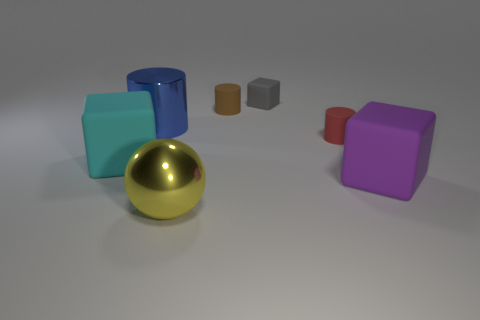Is the big purple block made of the same material as the yellow ball?
Your response must be concise. No. What number of other things are the same color as the large shiny cylinder?
Make the answer very short. 0. Are there more tiny yellow cylinders than large purple cubes?
Provide a short and direct response. No. There is a red cylinder; is it the same size as the block that is right of the gray matte object?
Your answer should be very brief. No. There is a block that is to the left of the gray rubber thing; what color is it?
Your answer should be compact. Cyan. How many red objects are tiny matte cylinders or small spheres?
Provide a succinct answer. 1. The large shiny sphere has what color?
Give a very brief answer. Yellow. Is there any other thing that has the same material as the large cyan block?
Your answer should be compact. Yes. Is the number of tiny matte cubes that are in front of the red rubber thing less than the number of large matte things that are behind the blue thing?
Your answer should be very brief. No. What is the shape of the object that is left of the large yellow sphere and behind the large cyan matte block?
Offer a terse response. Cylinder. 